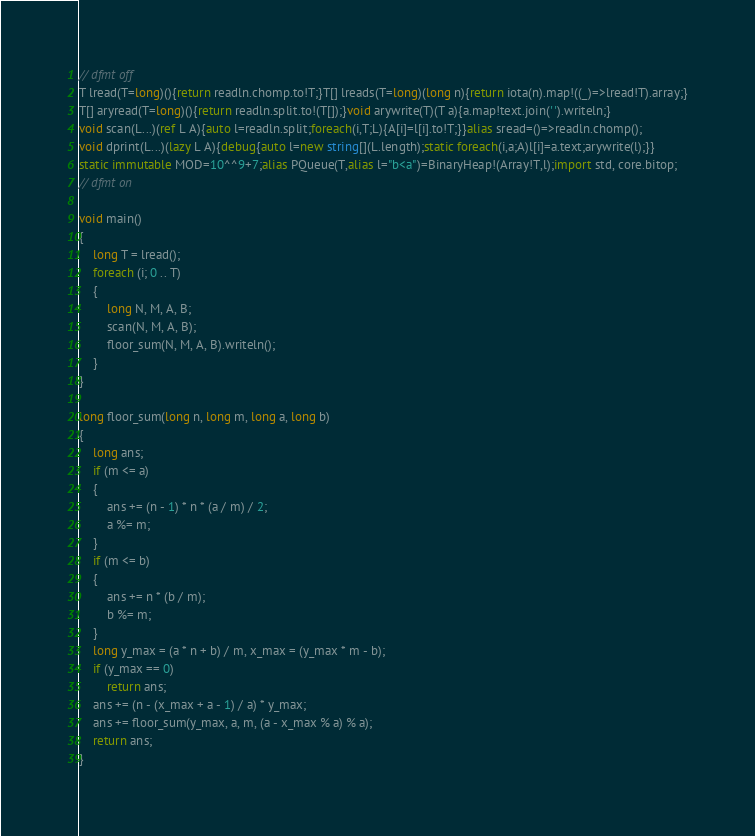Convert code to text. <code><loc_0><loc_0><loc_500><loc_500><_D_>// dfmt off
T lread(T=long)(){return readln.chomp.to!T;}T[] lreads(T=long)(long n){return iota(n).map!((_)=>lread!T).array;}
T[] aryread(T=long)(){return readln.split.to!(T[]);}void arywrite(T)(T a){a.map!text.join(' ').writeln;}
void scan(L...)(ref L A){auto l=readln.split;foreach(i,T;L){A[i]=l[i].to!T;}}alias sread=()=>readln.chomp();
void dprint(L...)(lazy L A){debug{auto l=new string[](L.length);static foreach(i,a;A)l[i]=a.text;arywrite(l);}}
static immutable MOD=10^^9+7;alias PQueue(T,alias l="b<a")=BinaryHeap!(Array!T,l);import std, core.bitop;
// dfmt on

void main()
{
    long T = lread();
    foreach (i; 0 .. T)
    {
        long N, M, A, B;
        scan(N, M, A, B);
        floor_sum(N, M, A, B).writeln();
    }
}

long floor_sum(long n, long m, long a, long b)
{
    long ans;
    if (m <= a)
    {
        ans += (n - 1) * n * (a / m) / 2;
        a %= m;
    }
    if (m <= b)
    {
        ans += n * (b / m);
        b %= m;
    }
    long y_max = (a * n + b) / m, x_max = (y_max * m - b);
    if (y_max == 0)
        return ans;
    ans += (n - (x_max + a - 1) / a) * y_max;
    ans += floor_sum(y_max, a, m, (a - x_max % a) % a);
    return ans;
}
</code> 